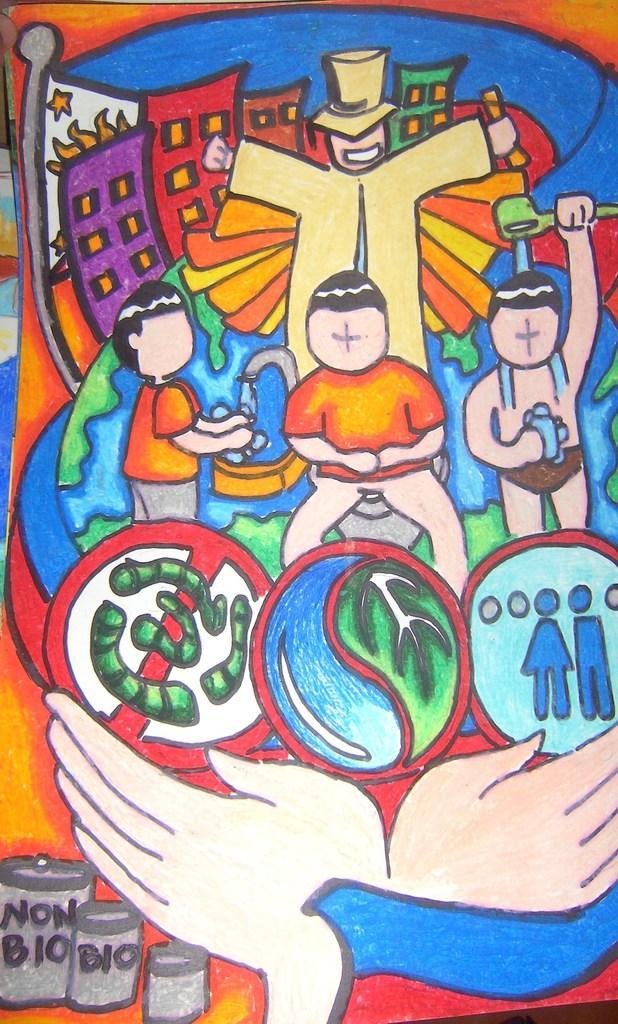In one or two sentences, can you explain what this image depicts? In the image we can see a painting. 